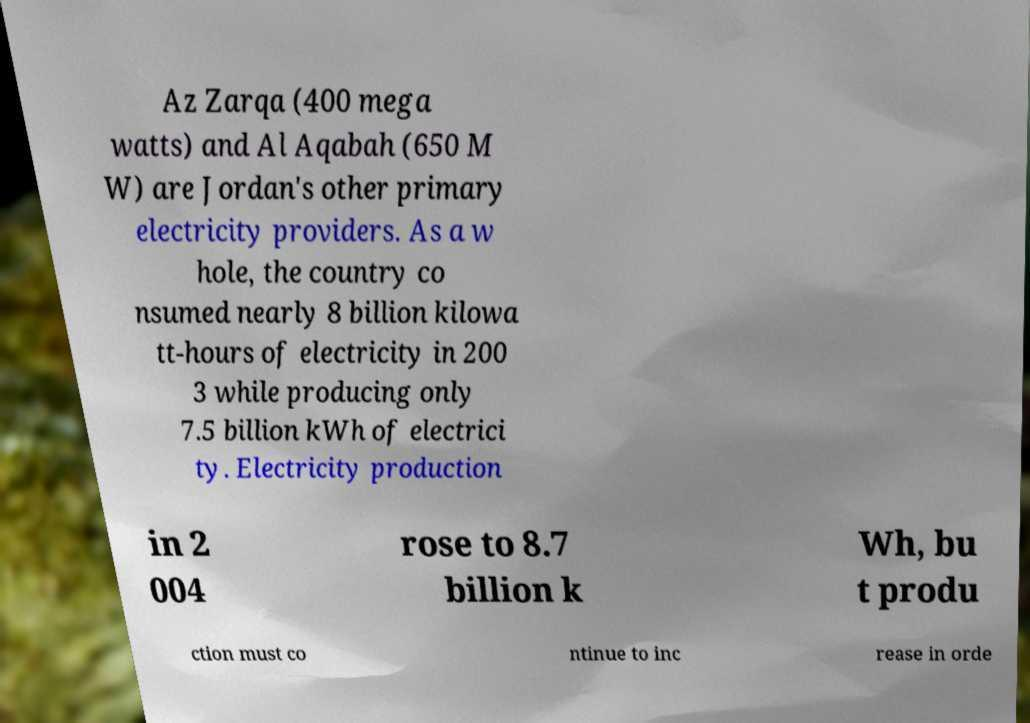Can you accurately transcribe the text from the provided image for me? Az Zarqa (400 mega watts) and Al Aqabah (650 M W) are Jordan's other primary electricity providers. As a w hole, the country co nsumed nearly 8 billion kilowa tt-hours of electricity in 200 3 while producing only 7.5 billion kWh of electrici ty. Electricity production in 2 004 rose to 8.7 billion k Wh, bu t produ ction must co ntinue to inc rease in orde 